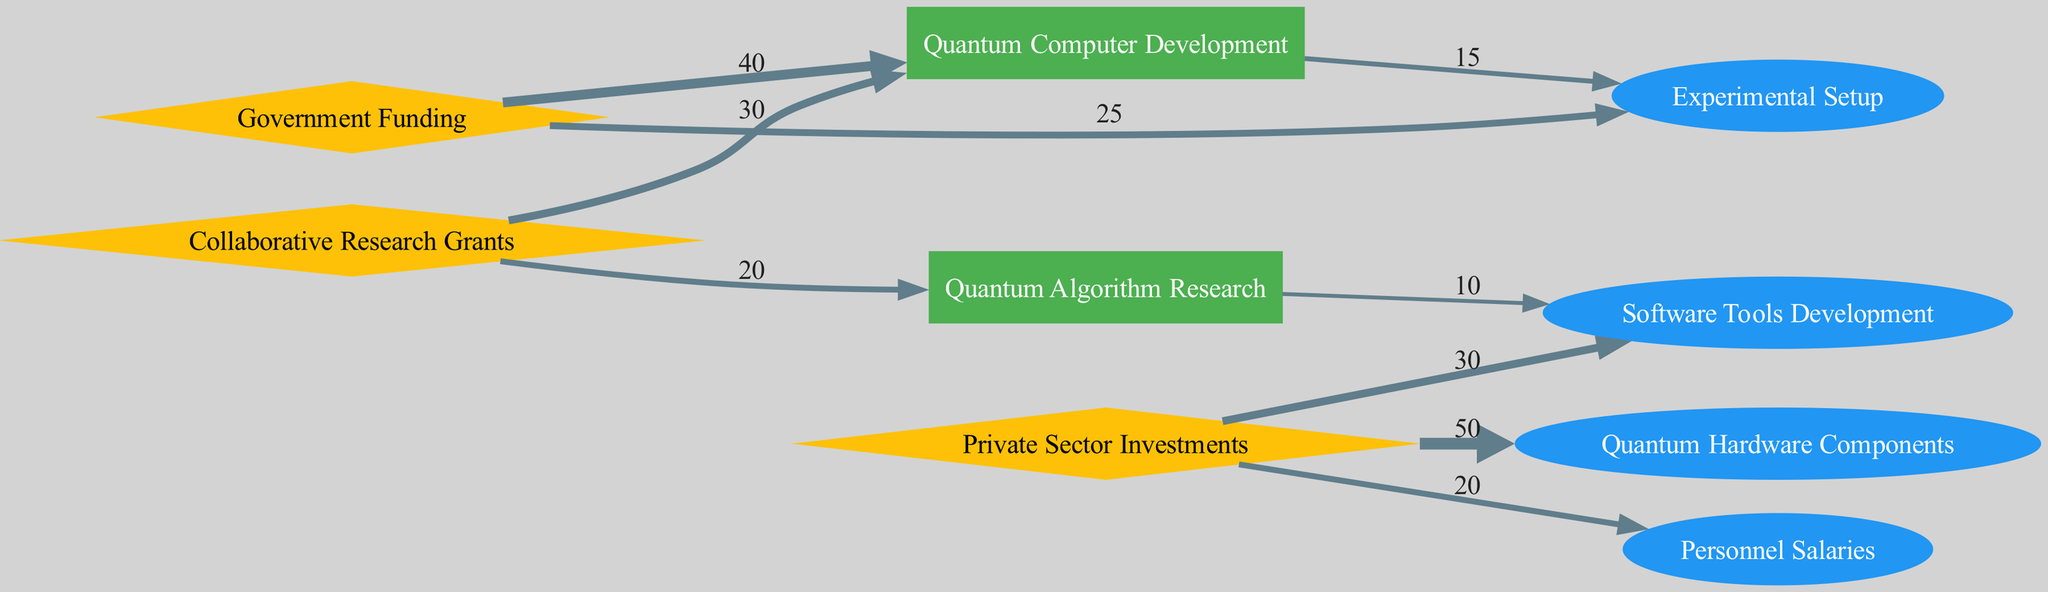What is the total amount of funding from Private Sector Investments? By examining the links originating from the Private Sector Investments node, we see three outgoing connections: to Quantum Hardware Components (50), Software Tools Development (30), and Personnel Salaries (20). Adding these values together, we have 50 + 30 + 20 = 100.
Answer: 100 Which research project received the most funding from Government Funding? Looking at the links from the Government Funding node, we see two outgoing connections: to Quantum Computer Development (40) and Experimental Setup (25). Since 40 is greater than 25, Quantum Computer Development is the project that received the most funding from this source.
Answer: Quantum Computer Development How many projects are involved in this funding allocation diagram? The nodes designated as projects are Quantum Computer Development and Quantum Algorithm Research, totaling two distinct projects in the diagram.
Answer: 2 What is the total funding allocation for Quantum Algorithm Research? Quantum Algorithm Research receives funding from two sources: 20 from Collaborative Research Grants and 10 from Quantum Computer Development. Adding these amounts gives us 20 + 10 = 30 as the total funding allocation for this project.
Answer: 30 Which expense category has the highest incoming funding? Reviewing the incoming funding for expense categories, Quantum Hardware Components receives 50 from Private Sector Investments, Software Tools Development gets 30 from Private Sector Investments and 10 from Quantum Algorithm Research, and Personnel Salaries gets 20 from Private Sector Investments. The highest value is 50 for Quantum Hardware Components.
Answer: Quantum Hardware Components How much funding does Experimental Setup receive in total? The Experimental Setup node has incoming funding from Government Funding (25) and Quantum Computer Development (15). Adding these together provides the total funding: 25 + 15 = 40.
Answer: 40 Which two nodes share a direct connection and how much funding is allocated? There is a direct connection between Quantum Computer Development and Experimental Setup, with an allocation of 15. This can be seen in the direct link that connects these two nodes.
Answer: 15 What fraction of the total funding for Quantum Computer Development comes from Government Funding? Quantum Computer Development has two incoming amounts: 30 from Collaborative Research Grants and 40 from Government Funding, making a total of 70. The amount from Government Funding is 40. The fraction is calculated as 40 / 70, which simplifies to approximately 0.57 or 57%.
Answer: 40 out of 70 or approximately 57% 